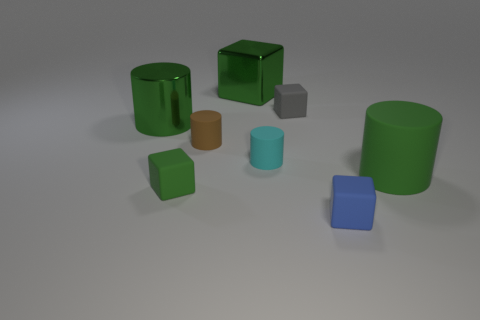Is the material of the green cylinder that is right of the blue matte cube the same as the green block behind the brown thing?
Your answer should be compact. No. There is a small gray thing; what number of things are to the left of it?
Provide a short and direct response. 5. How many cyan objects are either rubber objects or big rubber cubes?
Make the answer very short. 1. What material is the brown object that is the same size as the cyan object?
Ensure brevity in your answer.  Rubber. What shape is the small rubber thing that is to the right of the small cyan cylinder and behind the tiny cyan matte cylinder?
Make the answer very short. Cube. The other matte cylinder that is the same size as the brown cylinder is what color?
Offer a terse response. Cyan. Do the green cylinder on the right side of the metal cylinder and the green block on the left side of the large green cube have the same size?
Keep it short and to the point. No. How big is the green matte object that is in front of the big object that is on the right side of the small cylinder right of the green metal cube?
Your answer should be very brief. Small. The large thing that is in front of the green cylinder that is behind the cyan cylinder is what shape?
Your answer should be compact. Cylinder. There is a big metallic object on the right side of the small green matte cube; does it have the same color as the big matte cylinder?
Offer a terse response. Yes. 